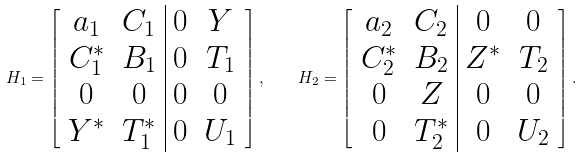<formula> <loc_0><loc_0><loc_500><loc_500>H _ { 1 } = \left [ \begin{array} { c c | c c } a _ { 1 } & C _ { 1 } & 0 & Y \\ C _ { 1 } ^ { * } & B _ { 1 } & 0 & T _ { 1 } \\ 0 & 0 & 0 & 0 \\ Y ^ { * } & T _ { 1 } ^ { * } & 0 & U _ { 1 } \end{array} \right ] , \quad H _ { 2 } = \left [ \begin{array} { c c | c c } a _ { 2 } & C _ { 2 } & 0 & 0 \\ C _ { 2 } ^ { * } & B _ { 2 } & Z ^ { * } & T _ { 2 } \\ 0 & Z & 0 & 0 \\ 0 & T _ { 2 } ^ { * } & 0 & U _ { 2 } \end{array} \right ] .</formula> 